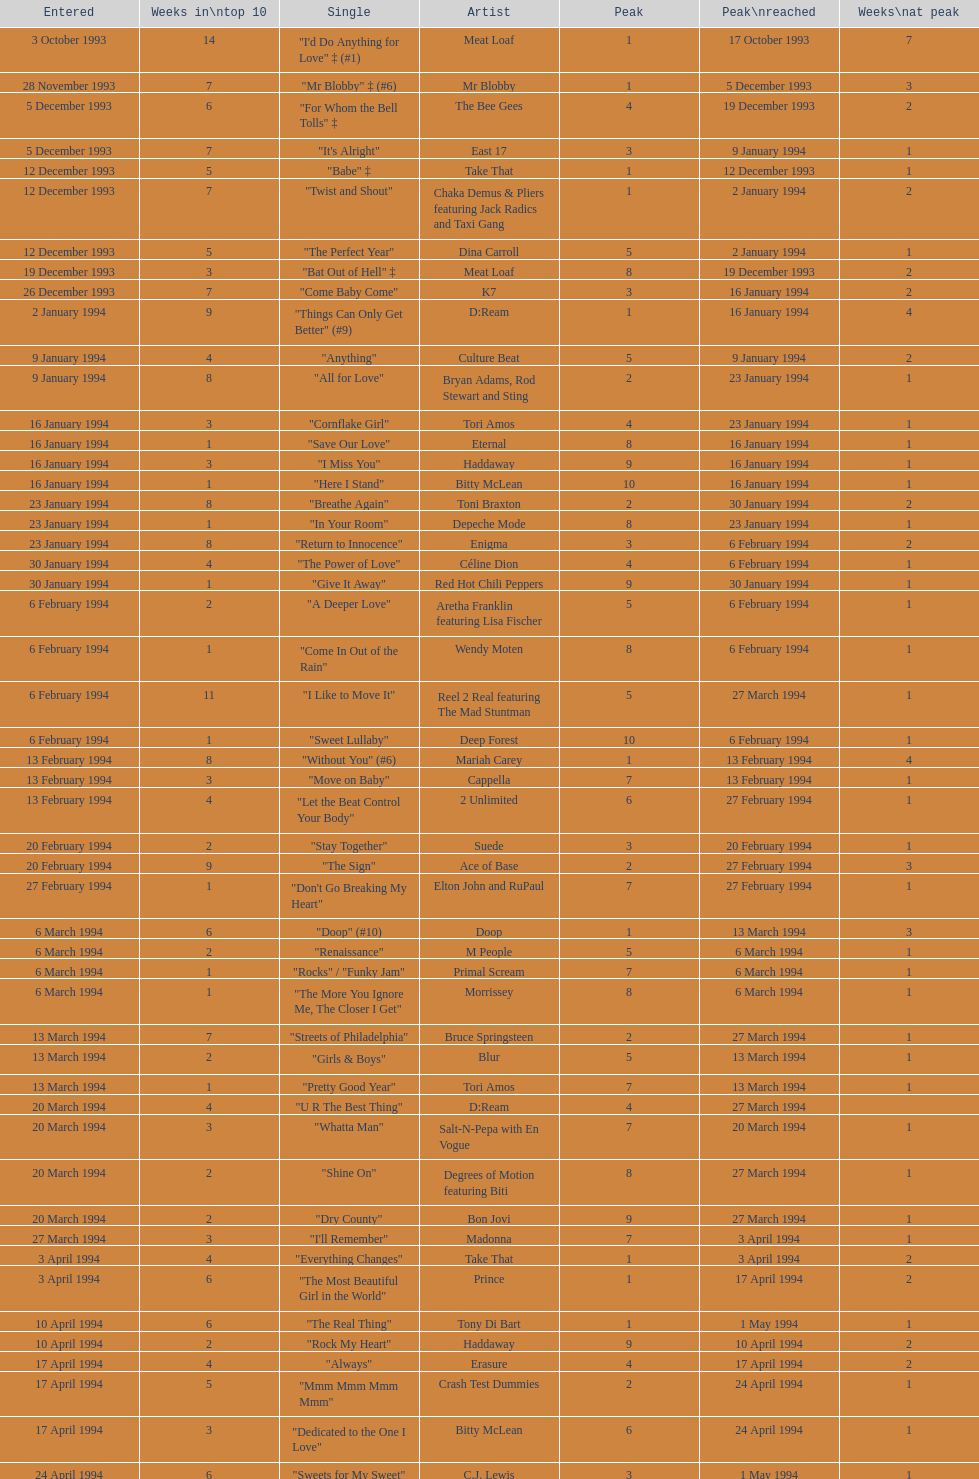Who is the artist whose single was introduced to the charts only on january 2, 1994? D:Ream. 